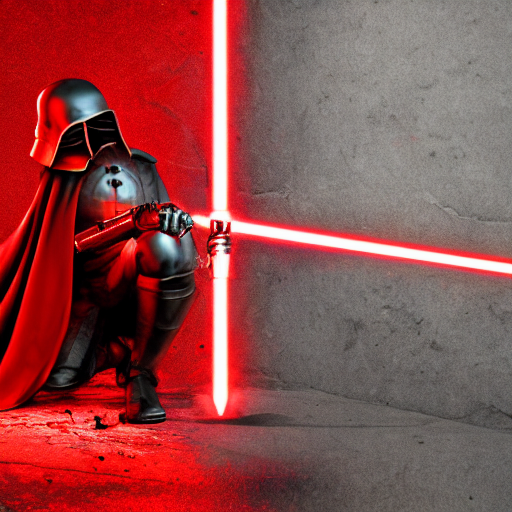Is the lighting overly unnatural? The lighting in the image appears to be dramatic and mood-enhancing, typical of artistic or theatrical settings. It aligns well with the subject's portrayal, and does not seem excessively unnatural for the style depicted. 